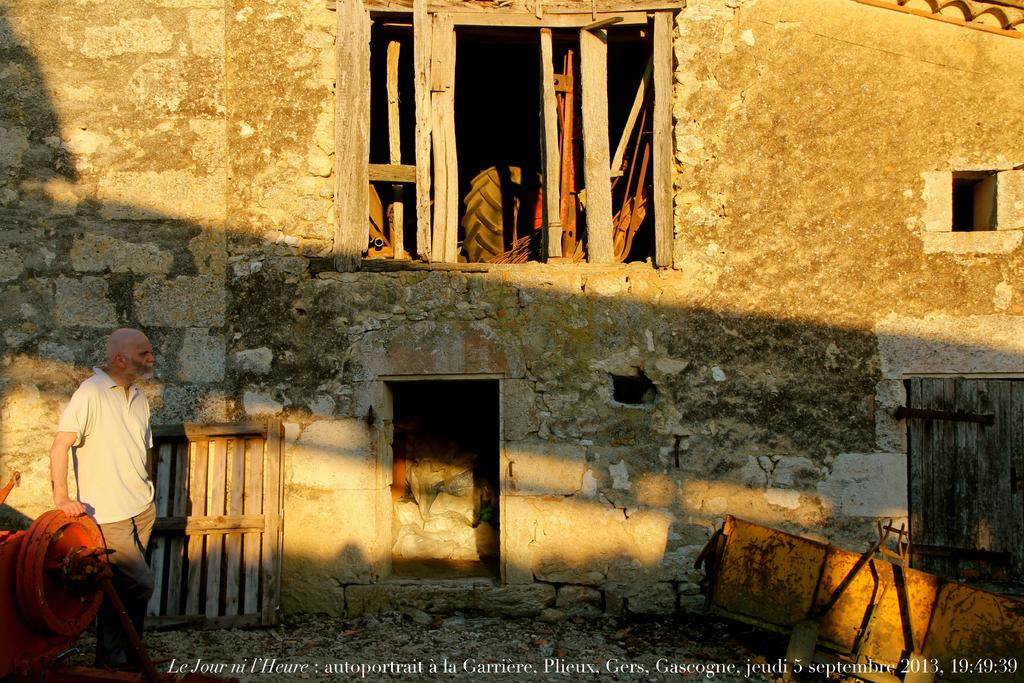Provide a one-sentence caption for the provided image. White text on the bottom reads a date of 5 septembre, 2013. 